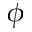<formula> <loc_0><loc_0><loc_500><loc_500>\phi</formula> 